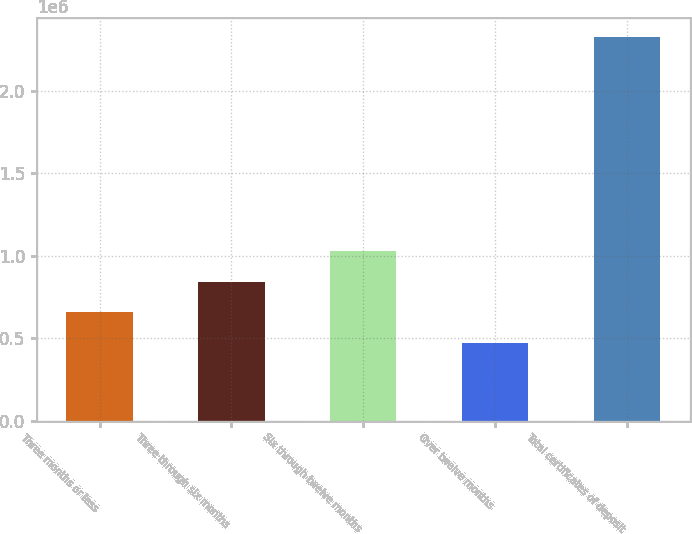Convert chart to OTSL. <chart><loc_0><loc_0><loc_500><loc_500><bar_chart><fcel>Three months or less<fcel>Three through six months<fcel>Six through twelve months<fcel>Over twelve months<fcel>Total certificates of deposit<nl><fcel>658361<fcel>843886<fcel>1.02941e+06<fcel>472836<fcel>2.32809e+06<nl></chart> 